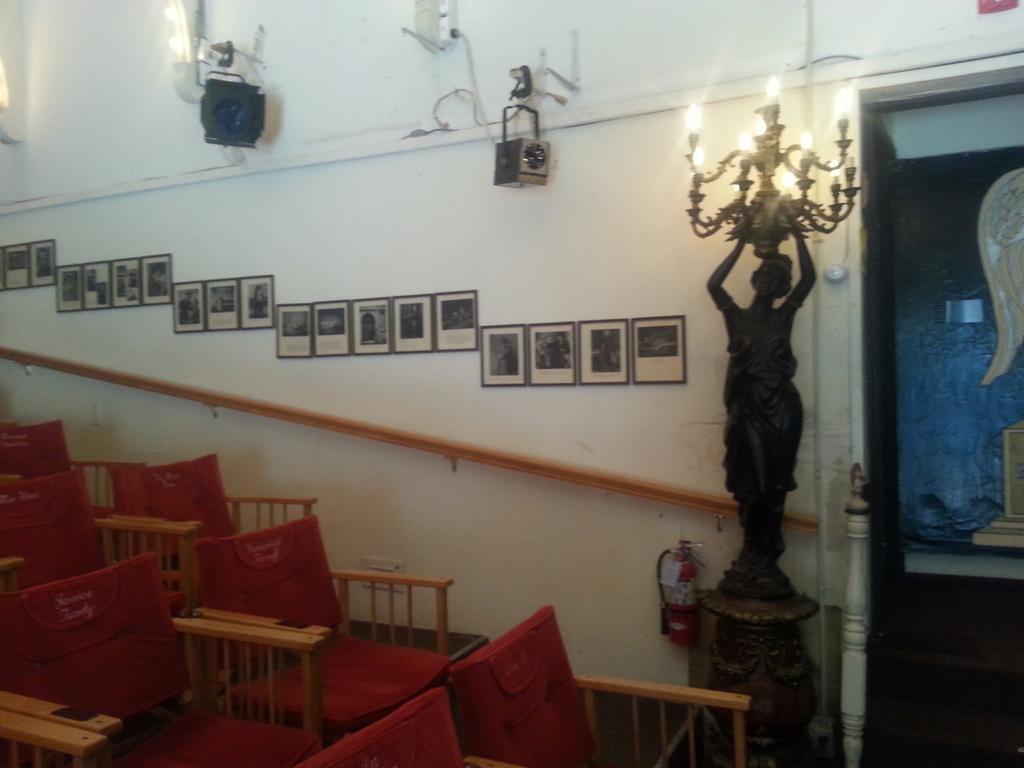Please provide a concise description of this image. In this image I can see few chairs, background I can see the statue, lights and I can also see few frames attached to the wall and the wall is in white color. 